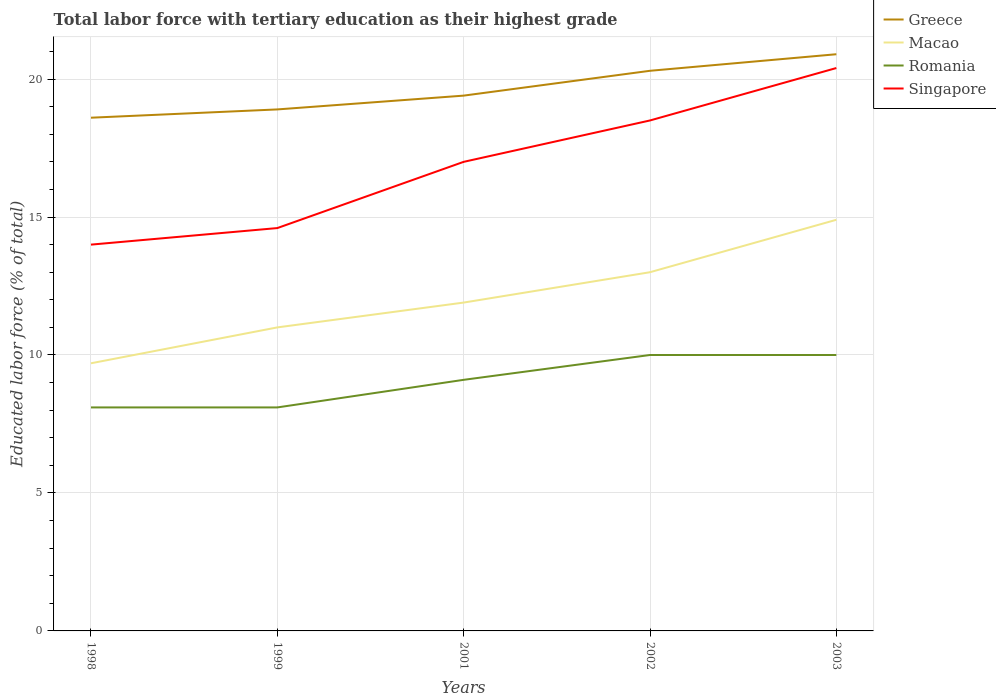Across all years, what is the maximum percentage of male labor force with tertiary education in Macao?
Give a very brief answer. 9.7. What is the total percentage of male labor force with tertiary education in Greece in the graph?
Provide a succinct answer. -1.4. What is the difference between the highest and the second highest percentage of male labor force with tertiary education in Macao?
Ensure brevity in your answer.  5.2. What is the difference between the highest and the lowest percentage of male labor force with tertiary education in Romania?
Provide a short and direct response. 3. How many lines are there?
Offer a very short reply. 4. How are the legend labels stacked?
Your response must be concise. Vertical. What is the title of the graph?
Make the answer very short. Total labor force with tertiary education as their highest grade. What is the label or title of the X-axis?
Keep it short and to the point. Years. What is the label or title of the Y-axis?
Offer a very short reply. Educated labor force (% of total). What is the Educated labor force (% of total) in Greece in 1998?
Your response must be concise. 18.6. What is the Educated labor force (% of total) of Macao in 1998?
Keep it short and to the point. 9.7. What is the Educated labor force (% of total) in Romania in 1998?
Your answer should be compact. 8.1. What is the Educated labor force (% of total) of Greece in 1999?
Make the answer very short. 18.9. What is the Educated labor force (% of total) in Romania in 1999?
Provide a succinct answer. 8.1. What is the Educated labor force (% of total) in Singapore in 1999?
Provide a succinct answer. 14.6. What is the Educated labor force (% of total) in Greece in 2001?
Keep it short and to the point. 19.4. What is the Educated labor force (% of total) in Macao in 2001?
Offer a very short reply. 11.9. What is the Educated labor force (% of total) of Romania in 2001?
Give a very brief answer. 9.1. What is the Educated labor force (% of total) in Singapore in 2001?
Offer a terse response. 17. What is the Educated labor force (% of total) in Greece in 2002?
Keep it short and to the point. 20.3. What is the Educated labor force (% of total) in Macao in 2002?
Provide a succinct answer. 13. What is the Educated labor force (% of total) in Singapore in 2002?
Make the answer very short. 18.5. What is the Educated labor force (% of total) of Greece in 2003?
Your response must be concise. 20.9. What is the Educated labor force (% of total) in Macao in 2003?
Provide a short and direct response. 14.9. What is the Educated labor force (% of total) of Romania in 2003?
Provide a short and direct response. 10. What is the Educated labor force (% of total) of Singapore in 2003?
Your answer should be compact. 20.4. Across all years, what is the maximum Educated labor force (% of total) of Greece?
Your answer should be very brief. 20.9. Across all years, what is the maximum Educated labor force (% of total) in Macao?
Ensure brevity in your answer.  14.9. Across all years, what is the maximum Educated labor force (% of total) of Singapore?
Give a very brief answer. 20.4. Across all years, what is the minimum Educated labor force (% of total) of Greece?
Your answer should be very brief. 18.6. Across all years, what is the minimum Educated labor force (% of total) in Macao?
Give a very brief answer. 9.7. Across all years, what is the minimum Educated labor force (% of total) of Romania?
Provide a succinct answer. 8.1. Across all years, what is the minimum Educated labor force (% of total) in Singapore?
Your answer should be compact. 14. What is the total Educated labor force (% of total) in Greece in the graph?
Ensure brevity in your answer.  98.1. What is the total Educated labor force (% of total) of Macao in the graph?
Provide a succinct answer. 60.5. What is the total Educated labor force (% of total) of Romania in the graph?
Provide a short and direct response. 45.3. What is the total Educated labor force (% of total) in Singapore in the graph?
Provide a succinct answer. 84.5. What is the difference between the Educated labor force (% of total) of Macao in 1998 and that in 1999?
Make the answer very short. -1.3. What is the difference between the Educated labor force (% of total) of Greece in 1998 and that in 2001?
Provide a short and direct response. -0.8. What is the difference between the Educated labor force (% of total) in Macao in 1998 and that in 2001?
Your answer should be very brief. -2.2. What is the difference between the Educated labor force (% of total) of Romania in 1998 and that in 2001?
Offer a terse response. -1. What is the difference between the Educated labor force (% of total) of Romania in 1998 and that in 2002?
Provide a succinct answer. -1.9. What is the difference between the Educated labor force (% of total) of Romania in 1998 and that in 2003?
Offer a very short reply. -1.9. What is the difference between the Educated labor force (% of total) in Greece in 1999 and that in 2001?
Make the answer very short. -0.5. What is the difference between the Educated labor force (% of total) of Macao in 1999 and that in 2001?
Ensure brevity in your answer.  -0.9. What is the difference between the Educated labor force (% of total) of Macao in 1999 and that in 2002?
Ensure brevity in your answer.  -2. What is the difference between the Educated labor force (% of total) of Greece in 1999 and that in 2003?
Offer a terse response. -2. What is the difference between the Educated labor force (% of total) of Macao in 1999 and that in 2003?
Give a very brief answer. -3.9. What is the difference between the Educated labor force (% of total) of Romania in 1999 and that in 2003?
Make the answer very short. -1.9. What is the difference between the Educated labor force (% of total) of Singapore in 1999 and that in 2003?
Provide a succinct answer. -5.8. What is the difference between the Educated labor force (% of total) in Greece in 2001 and that in 2002?
Provide a succinct answer. -0.9. What is the difference between the Educated labor force (% of total) of Macao in 2001 and that in 2003?
Give a very brief answer. -3. What is the difference between the Educated labor force (% of total) of Romania in 2001 and that in 2003?
Offer a very short reply. -0.9. What is the difference between the Educated labor force (% of total) of Greece in 2002 and that in 2003?
Give a very brief answer. -0.6. What is the difference between the Educated labor force (% of total) in Macao in 2002 and that in 2003?
Provide a short and direct response. -1.9. What is the difference between the Educated labor force (% of total) in Singapore in 2002 and that in 2003?
Make the answer very short. -1.9. What is the difference between the Educated labor force (% of total) in Macao in 1998 and the Educated labor force (% of total) in Romania in 1999?
Provide a short and direct response. 1.6. What is the difference between the Educated labor force (% of total) in Greece in 1998 and the Educated labor force (% of total) in Romania in 2001?
Provide a succinct answer. 9.5. What is the difference between the Educated labor force (% of total) in Greece in 1998 and the Educated labor force (% of total) in Singapore in 2001?
Offer a very short reply. 1.6. What is the difference between the Educated labor force (% of total) in Romania in 1998 and the Educated labor force (% of total) in Singapore in 2001?
Keep it short and to the point. -8.9. What is the difference between the Educated labor force (% of total) in Greece in 1998 and the Educated labor force (% of total) in Macao in 2002?
Your response must be concise. 5.6. What is the difference between the Educated labor force (% of total) of Greece in 1998 and the Educated labor force (% of total) of Macao in 2003?
Offer a terse response. 3.7. What is the difference between the Educated labor force (% of total) of Macao in 1998 and the Educated labor force (% of total) of Singapore in 2003?
Your answer should be compact. -10.7. What is the difference between the Educated labor force (% of total) in Greece in 1999 and the Educated labor force (% of total) in Singapore in 2001?
Offer a very short reply. 1.9. What is the difference between the Educated labor force (% of total) of Macao in 1999 and the Educated labor force (% of total) of Romania in 2001?
Provide a short and direct response. 1.9. What is the difference between the Educated labor force (% of total) of Macao in 1999 and the Educated labor force (% of total) of Singapore in 2001?
Offer a very short reply. -6. What is the difference between the Educated labor force (% of total) of Greece in 1999 and the Educated labor force (% of total) of Macao in 2002?
Your answer should be very brief. 5.9. What is the difference between the Educated labor force (% of total) in Greece in 1999 and the Educated labor force (% of total) in Singapore in 2002?
Keep it short and to the point. 0.4. What is the difference between the Educated labor force (% of total) of Macao in 1999 and the Educated labor force (% of total) of Singapore in 2003?
Your answer should be compact. -9.4. What is the difference between the Educated labor force (% of total) in Romania in 1999 and the Educated labor force (% of total) in Singapore in 2003?
Your answer should be very brief. -12.3. What is the difference between the Educated labor force (% of total) in Macao in 2001 and the Educated labor force (% of total) in Romania in 2002?
Provide a succinct answer. 1.9. What is the difference between the Educated labor force (% of total) of Greece in 2001 and the Educated labor force (% of total) of Macao in 2003?
Give a very brief answer. 4.5. What is the difference between the Educated labor force (% of total) of Greece in 2001 and the Educated labor force (% of total) of Singapore in 2003?
Provide a short and direct response. -1. What is the difference between the Educated labor force (% of total) in Macao in 2001 and the Educated labor force (% of total) in Singapore in 2003?
Give a very brief answer. -8.5. What is the difference between the Educated labor force (% of total) in Romania in 2001 and the Educated labor force (% of total) in Singapore in 2003?
Offer a very short reply. -11.3. What is the difference between the Educated labor force (% of total) in Greece in 2002 and the Educated labor force (% of total) in Macao in 2003?
Keep it short and to the point. 5.4. What is the difference between the Educated labor force (% of total) in Greece in 2002 and the Educated labor force (% of total) in Romania in 2003?
Offer a terse response. 10.3. What is the average Educated labor force (% of total) in Greece per year?
Your answer should be very brief. 19.62. What is the average Educated labor force (% of total) in Macao per year?
Your answer should be compact. 12.1. What is the average Educated labor force (% of total) in Romania per year?
Ensure brevity in your answer.  9.06. What is the average Educated labor force (% of total) in Singapore per year?
Keep it short and to the point. 16.9. In the year 1998, what is the difference between the Educated labor force (% of total) in Greece and Educated labor force (% of total) in Singapore?
Your answer should be very brief. 4.6. In the year 1999, what is the difference between the Educated labor force (% of total) of Greece and Educated labor force (% of total) of Macao?
Keep it short and to the point. 7.9. In the year 1999, what is the difference between the Educated labor force (% of total) of Greece and Educated labor force (% of total) of Romania?
Offer a very short reply. 10.8. In the year 1999, what is the difference between the Educated labor force (% of total) in Greece and Educated labor force (% of total) in Singapore?
Your answer should be very brief. 4.3. In the year 1999, what is the difference between the Educated labor force (% of total) of Macao and Educated labor force (% of total) of Romania?
Provide a short and direct response. 2.9. In the year 1999, what is the difference between the Educated labor force (% of total) in Macao and Educated labor force (% of total) in Singapore?
Make the answer very short. -3.6. In the year 2001, what is the difference between the Educated labor force (% of total) in Greece and Educated labor force (% of total) in Macao?
Offer a terse response. 7.5. In the year 2001, what is the difference between the Educated labor force (% of total) in Greece and Educated labor force (% of total) in Romania?
Provide a short and direct response. 10.3. In the year 2001, what is the difference between the Educated labor force (% of total) of Macao and Educated labor force (% of total) of Singapore?
Your response must be concise. -5.1. In the year 2002, what is the difference between the Educated labor force (% of total) of Greece and Educated labor force (% of total) of Romania?
Give a very brief answer. 10.3. In the year 2002, what is the difference between the Educated labor force (% of total) in Macao and Educated labor force (% of total) in Romania?
Offer a very short reply. 3. In the year 2002, what is the difference between the Educated labor force (% of total) of Macao and Educated labor force (% of total) of Singapore?
Your answer should be very brief. -5.5. In the year 2002, what is the difference between the Educated labor force (% of total) of Romania and Educated labor force (% of total) of Singapore?
Provide a succinct answer. -8.5. What is the ratio of the Educated labor force (% of total) of Greece in 1998 to that in 1999?
Your response must be concise. 0.98. What is the ratio of the Educated labor force (% of total) of Macao in 1998 to that in 1999?
Your answer should be very brief. 0.88. What is the ratio of the Educated labor force (% of total) of Romania in 1998 to that in 1999?
Offer a terse response. 1. What is the ratio of the Educated labor force (% of total) of Singapore in 1998 to that in 1999?
Ensure brevity in your answer.  0.96. What is the ratio of the Educated labor force (% of total) of Greece in 1998 to that in 2001?
Ensure brevity in your answer.  0.96. What is the ratio of the Educated labor force (% of total) in Macao in 1998 to that in 2001?
Offer a terse response. 0.82. What is the ratio of the Educated labor force (% of total) in Romania in 1998 to that in 2001?
Provide a succinct answer. 0.89. What is the ratio of the Educated labor force (% of total) in Singapore in 1998 to that in 2001?
Offer a terse response. 0.82. What is the ratio of the Educated labor force (% of total) of Greece in 1998 to that in 2002?
Offer a terse response. 0.92. What is the ratio of the Educated labor force (% of total) of Macao in 1998 to that in 2002?
Keep it short and to the point. 0.75. What is the ratio of the Educated labor force (% of total) in Romania in 1998 to that in 2002?
Offer a terse response. 0.81. What is the ratio of the Educated labor force (% of total) in Singapore in 1998 to that in 2002?
Offer a very short reply. 0.76. What is the ratio of the Educated labor force (% of total) of Greece in 1998 to that in 2003?
Your answer should be compact. 0.89. What is the ratio of the Educated labor force (% of total) of Macao in 1998 to that in 2003?
Provide a succinct answer. 0.65. What is the ratio of the Educated labor force (% of total) in Romania in 1998 to that in 2003?
Your answer should be compact. 0.81. What is the ratio of the Educated labor force (% of total) in Singapore in 1998 to that in 2003?
Your answer should be very brief. 0.69. What is the ratio of the Educated labor force (% of total) of Greece in 1999 to that in 2001?
Ensure brevity in your answer.  0.97. What is the ratio of the Educated labor force (% of total) in Macao in 1999 to that in 2001?
Give a very brief answer. 0.92. What is the ratio of the Educated labor force (% of total) of Romania in 1999 to that in 2001?
Your answer should be very brief. 0.89. What is the ratio of the Educated labor force (% of total) in Singapore in 1999 to that in 2001?
Keep it short and to the point. 0.86. What is the ratio of the Educated labor force (% of total) of Macao in 1999 to that in 2002?
Give a very brief answer. 0.85. What is the ratio of the Educated labor force (% of total) of Romania in 1999 to that in 2002?
Offer a very short reply. 0.81. What is the ratio of the Educated labor force (% of total) in Singapore in 1999 to that in 2002?
Your answer should be compact. 0.79. What is the ratio of the Educated labor force (% of total) in Greece in 1999 to that in 2003?
Give a very brief answer. 0.9. What is the ratio of the Educated labor force (% of total) in Macao in 1999 to that in 2003?
Provide a succinct answer. 0.74. What is the ratio of the Educated labor force (% of total) of Romania in 1999 to that in 2003?
Keep it short and to the point. 0.81. What is the ratio of the Educated labor force (% of total) in Singapore in 1999 to that in 2003?
Your answer should be compact. 0.72. What is the ratio of the Educated labor force (% of total) in Greece in 2001 to that in 2002?
Offer a terse response. 0.96. What is the ratio of the Educated labor force (% of total) of Macao in 2001 to that in 2002?
Keep it short and to the point. 0.92. What is the ratio of the Educated labor force (% of total) in Romania in 2001 to that in 2002?
Make the answer very short. 0.91. What is the ratio of the Educated labor force (% of total) of Singapore in 2001 to that in 2002?
Your response must be concise. 0.92. What is the ratio of the Educated labor force (% of total) of Greece in 2001 to that in 2003?
Ensure brevity in your answer.  0.93. What is the ratio of the Educated labor force (% of total) in Macao in 2001 to that in 2003?
Offer a very short reply. 0.8. What is the ratio of the Educated labor force (% of total) in Romania in 2001 to that in 2003?
Offer a terse response. 0.91. What is the ratio of the Educated labor force (% of total) in Singapore in 2001 to that in 2003?
Make the answer very short. 0.83. What is the ratio of the Educated labor force (% of total) of Greece in 2002 to that in 2003?
Keep it short and to the point. 0.97. What is the ratio of the Educated labor force (% of total) of Macao in 2002 to that in 2003?
Your response must be concise. 0.87. What is the ratio of the Educated labor force (% of total) of Singapore in 2002 to that in 2003?
Your response must be concise. 0.91. What is the difference between the highest and the second highest Educated labor force (% of total) in Greece?
Provide a succinct answer. 0.6. What is the difference between the highest and the second highest Educated labor force (% of total) in Macao?
Your answer should be very brief. 1.9. What is the difference between the highest and the second highest Educated labor force (% of total) of Romania?
Give a very brief answer. 0. What is the difference between the highest and the second highest Educated labor force (% of total) in Singapore?
Give a very brief answer. 1.9. What is the difference between the highest and the lowest Educated labor force (% of total) in Singapore?
Your response must be concise. 6.4. 